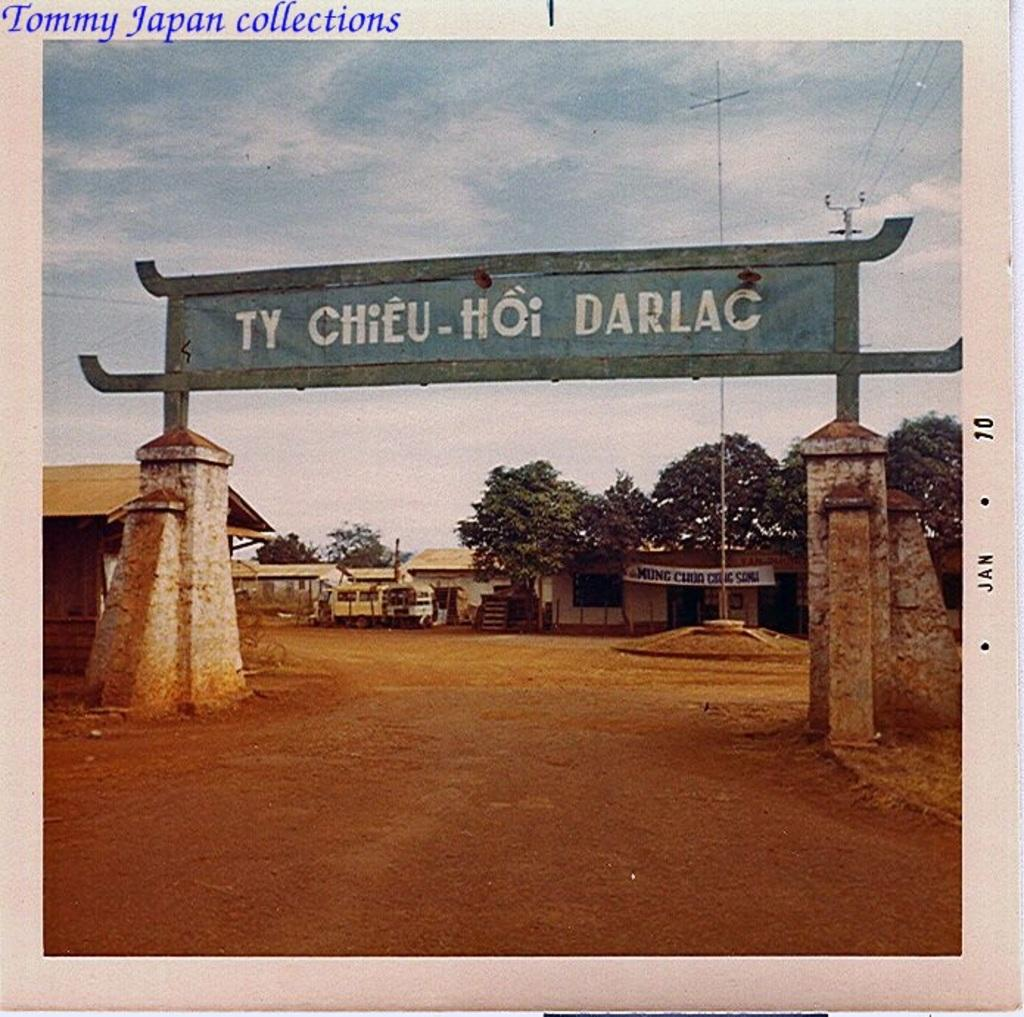<image>
Relay a brief, clear account of the picture shown. An archway sign over a road entrance that reads Ty Chieu-Hoi Darlac 